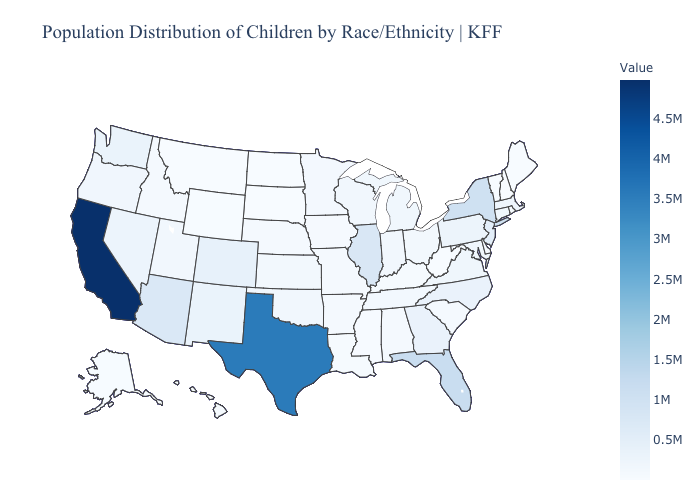Does Rhode Island have the highest value in the Northeast?
Write a very short answer. No. Among the states that border North Dakota , which have the lowest value?
Give a very brief answer. South Dakota. Does Texas have a higher value than Wisconsin?
Give a very brief answer. Yes. Does Vermont have the lowest value in the USA?
Be succinct. Yes. Among the states that border Alabama , does Georgia have the highest value?
Give a very brief answer. No. Is the legend a continuous bar?
Answer briefly. Yes. 